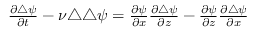Convert formula to latex. <formula><loc_0><loc_0><loc_500><loc_500>\begin{array} { r } { \frac { \partial \triangle \psi } { \partial t } - \nu \triangle \triangle \psi = \frac { \partial \psi } { \partial x } \frac { \partial \triangle \psi } { \partial z } - \frac { \partial \psi } { \partial z } \frac { \partial \triangle \psi } { \partial x } } \end{array}</formula> 